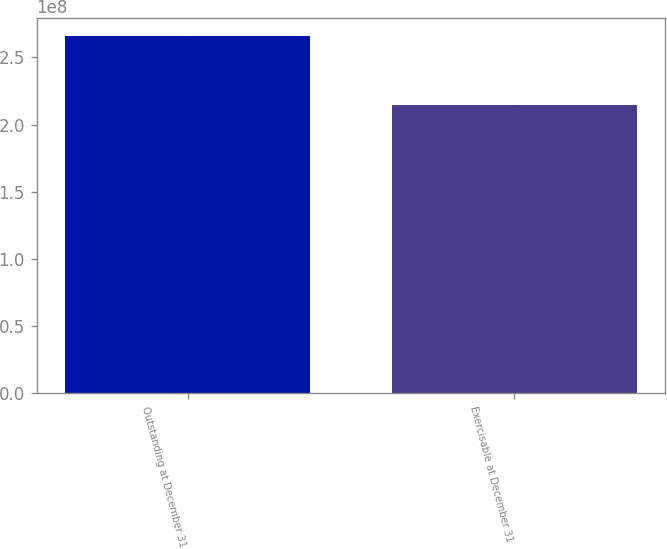Convert chart to OTSL. <chart><loc_0><loc_0><loc_500><loc_500><bar_chart><fcel>Outstanding at December 31<fcel>Exercisable at December 31<nl><fcel>2.65783e+08<fcel>2.1488e+08<nl></chart> 